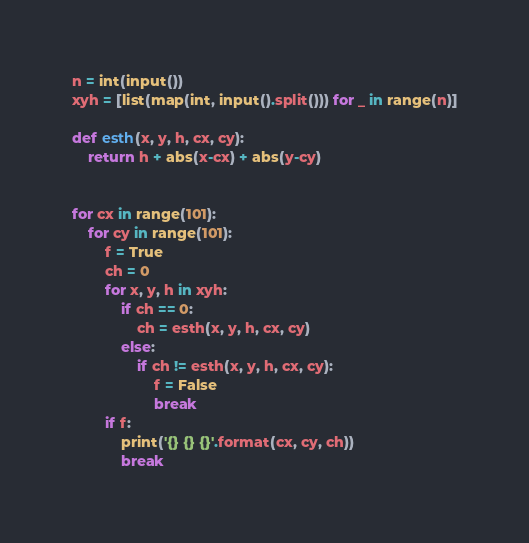Convert code to text. <code><loc_0><loc_0><loc_500><loc_500><_Python_>n = int(input())
xyh = [list(map(int, input().split())) for _ in range(n)]

def esth(x, y, h, cx, cy):
    return h + abs(x-cx) + abs(y-cy)


for cx in range(101):
    for cy in range(101):
        f = True
        ch = 0
        for x, y, h in xyh:
            if ch == 0:
                ch = esth(x, y, h, cx, cy)
            else:
                if ch != esth(x, y, h, cx, cy):
                    f = False
                    break
        if f:
            print('{} {} {}'.format(cx, cy, ch))
            break</code> 